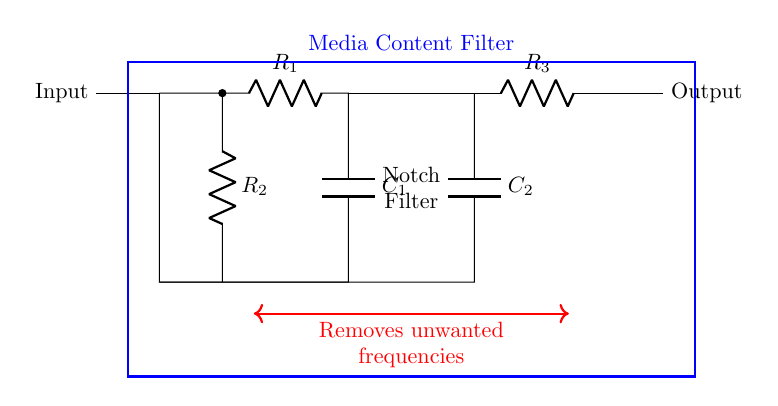What is the input component in this circuit? The input component is labeled at the left of the circuit as 'Input'. This is identified by examining the leftmost part of the diagram where the circuit receives its signal or media content.
Answer: Input What type of filter is represented in this circuit? The circuit diagram specifies a 'Notch Filter' in the labeled section, which indicates that the primary purpose of this circuit is to eliminate specific unwanted frequencies from the signal.
Answer: Notch Filter How many resistors are present in this circuit? There are three resistors in this circuit, designated as R1, R2, and R3. They are represented by three distinct labels in the circuit diagram.
Answer: Three What is the purpose of the capacitor C1 in this circuit? Capacitor C1 is part of the filtering mechanism in the notch filter, helping to determine the frequency response of the circuit. By blocking certain frequencies and allowing others to pass, it plays a crucial role in filtering out unwanted signals.
Answer: Filtering What is the output of this notch filter? The output is indicated by the label 'Output' located at the right end of the circuit. This shows where the processed signal, free from unwanted frequencies, will emerge from the filter.
Answer: Output Explain how the notch filter removes unwanted frequencies. The notch filter achieves its function through the combination of resistors and capacitors. The design causes certain frequencies to experience attenuation while permitting others to pass through. Specifically, the arrangement of the components is such that they create a frequency response that is low at the center frequency, leading to effective frequency removal at that specific point while maintaining the integrity of the surrounding frequencies.
Answer: Frequency attenuation What happens to unwanted frequencies in this circuit? Unwanted frequencies are effectively removed as the circuit is designed to attenuate those specific frequencies while allowing desirable signals to pass through. This is characteristic of how a notch filter functions, where it targets a narrow band of frequencies for rejection.
Answer: Removed 